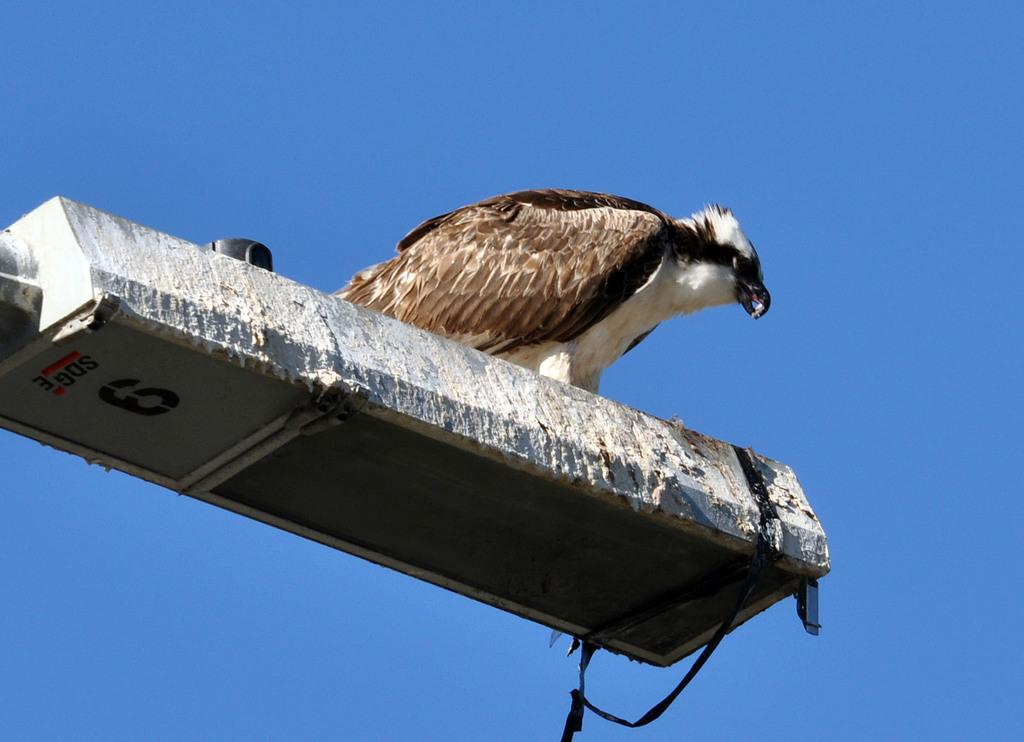What type of animal is present in the image? There is a bird in the image. Where is the bird located in the image? The bird is on an object. Can you describe the background of the image? The background of the image is colored. What is the bird's secretary doing in the image? There is no secretary present in the image, as it features a bird on an object with a colored background. 